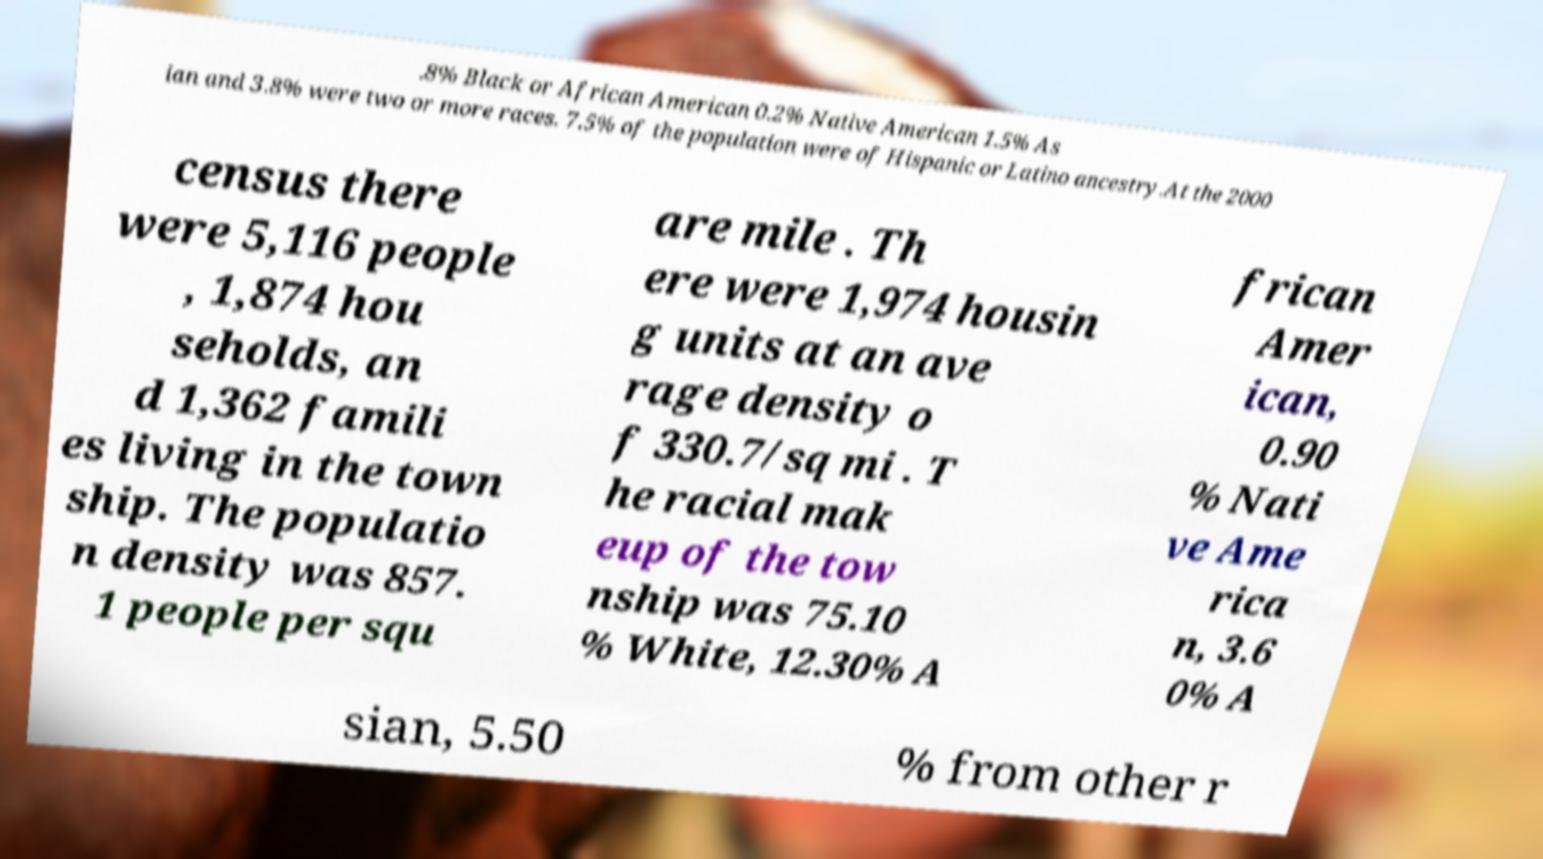Can you read and provide the text displayed in the image?This photo seems to have some interesting text. Can you extract and type it out for me? .8% Black or African American 0.2% Native American 1.5% As ian and 3.8% were two or more races. 7.5% of the population were of Hispanic or Latino ancestry.At the 2000 census there were 5,116 people , 1,874 hou seholds, an d 1,362 famili es living in the town ship. The populatio n density was 857. 1 people per squ are mile . Th ere were 1,974 housin g units at an ave rage density o f 330.7/sq mi . T he racial mak eup of the tow nship was 75.10 % White, 12.30% A frican Amer ican, 0.90 % Nati ve Ame rica n, 3.6 0% A sian, 5.50 % from other r 